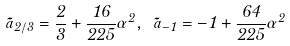Convert formula to latex. <formula><loc_0><loc_0><loc_500><loc_500>\tilde { a } _ { 2 / 3 } = \frac { 2 } { 3 } + \frac { 1 6 } { 2 2 5 } \alpha ^ { 2 } , \ \tilde { a } _ { - 1 } = - 1 + \frac { 6 4 } { 2 2 5 } \alpha ^ { 2 }</formula> 